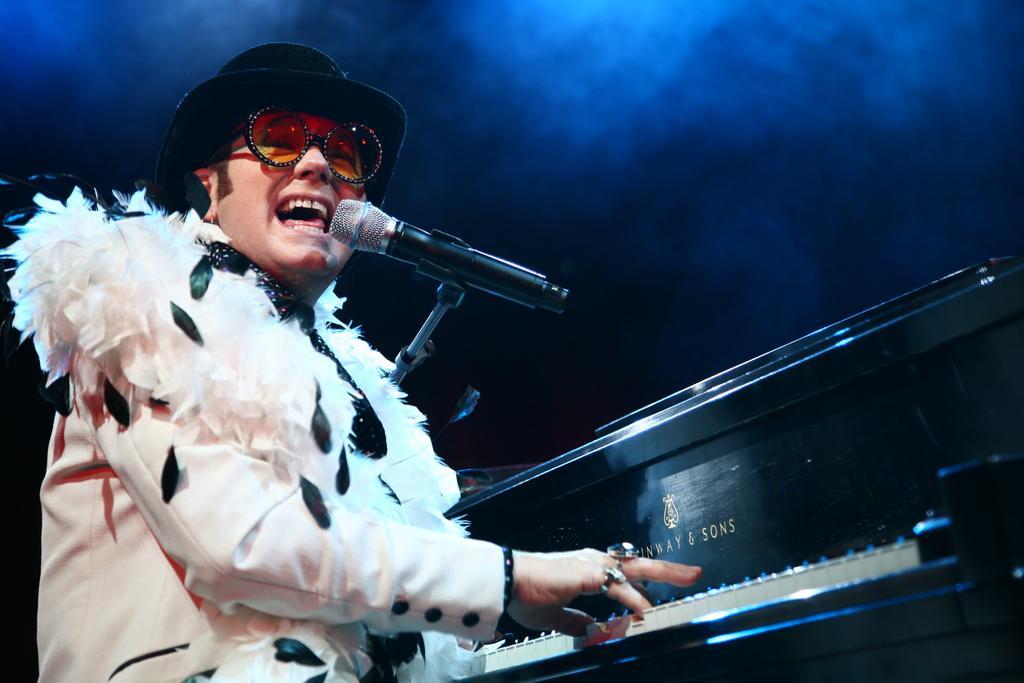Describe this image in one or two sentences. Here in this picture we can see a person playing a piano, which is in front of him and singing a song with a microphone present in front of him and we can see he is wearing a jacket, goggles and hat on him over there. 